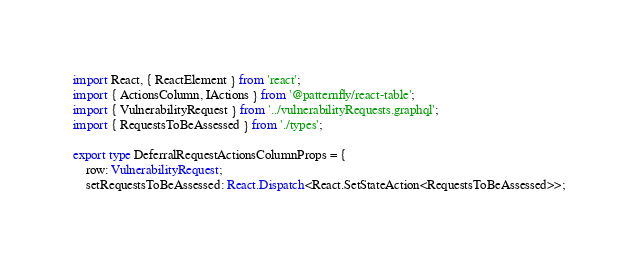Convert code to text. <code><loc_0><loc_0><loc_500><loc_500><_TypeScript_>import React, { ReactElement } from 'react';
import { ActionsColumn, IActions } from '@patternfly/react-table';
import { VulnerabilityRequest } from '../vulnerabilityRequests.graphql';
import { RequestsToBeAssessed } from './types';

export type DeferralRequestActionsColumnProps = {
    row: VulnerabilityRequest;
    setRequestsToBeAssessed: React.Dispatch<React.SetStateAction<RequestsToBeAssessed>>;</code> 